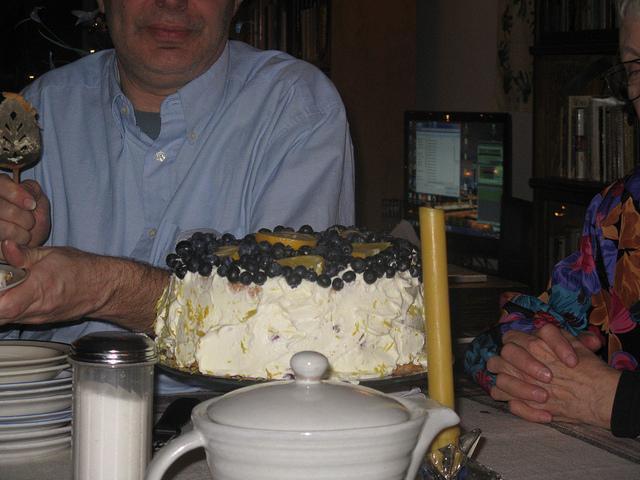How many people are visible?
Give a very brief answer. 2. How many elephant feet are lifted?
Give a very brief answer. 0. 